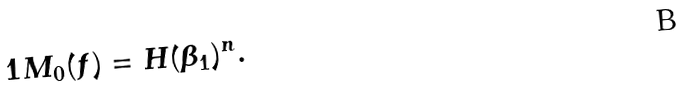<formula> <loc_0><loc_0><loc_500><loc_500>1 M _ { 0 } ( f ) = H ( \beta _ { 1 } ) ^ { n } .</formula> 